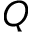Convert formula to latex. <formula><loc_0><loc_0><loc_500><loc_500>Q</formula> 